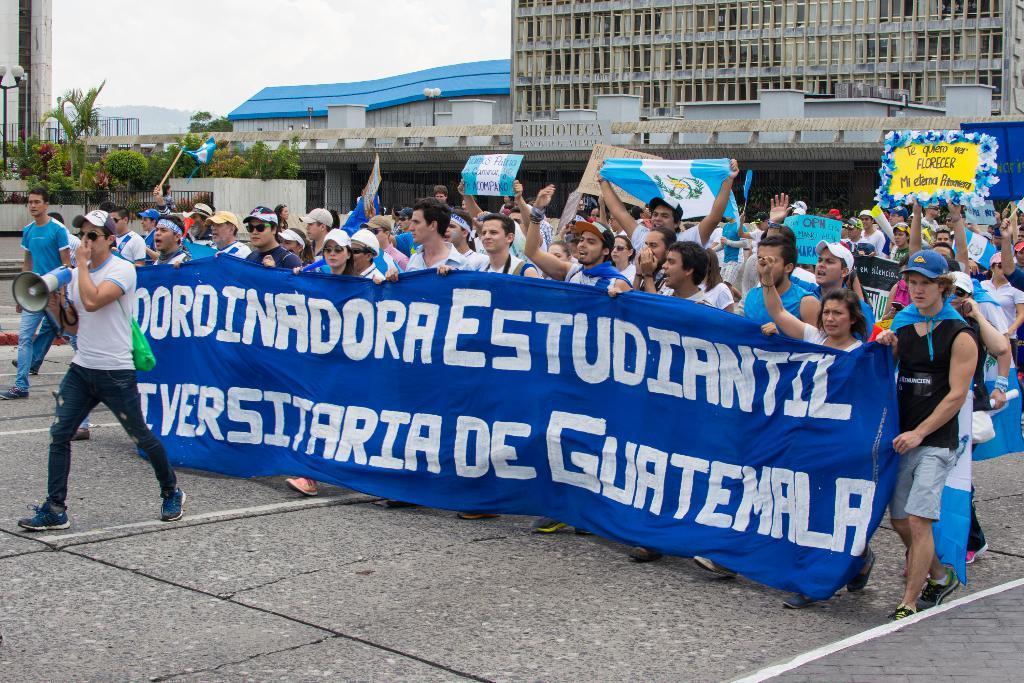In one or two sentences, can you explain what this image depicts? In this image I can see there are crowd of people visible and in the foreground I can see a person holding a mike on the left side and I can see a blue color cloth holding by persons on the cloth I can see text ,at the top I can see buildings and trees and bushes and the sky. 